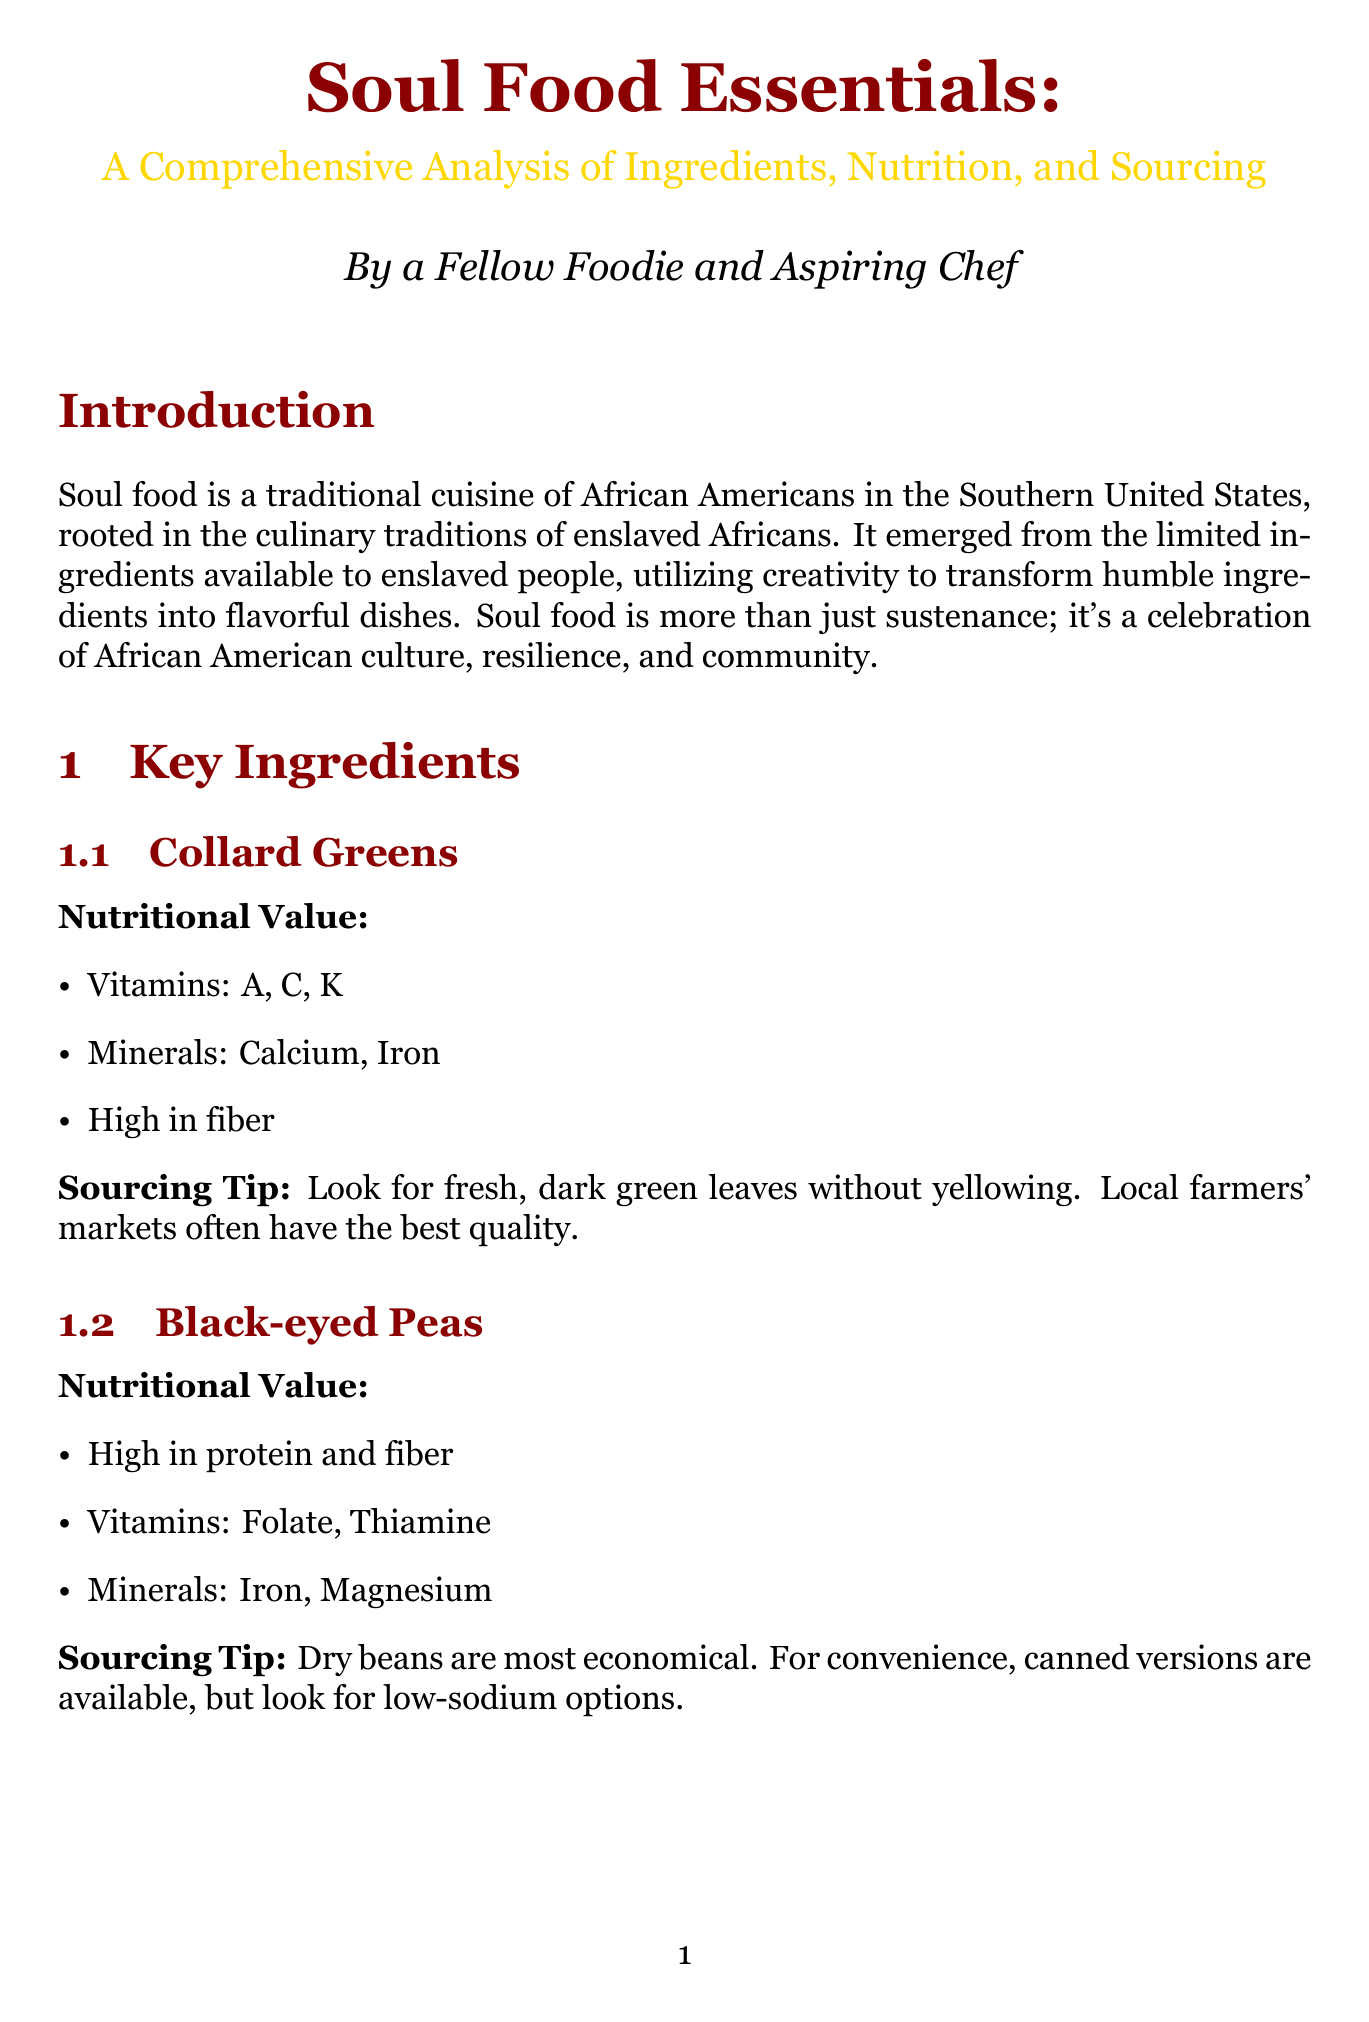What are the key vitamins found in collard greens? Collard greens contain vitamins A, C, and K, as stated in the nutritional value section.
Answer: A, C, K What is a common cooking technique for fried chicken? The document describes frying as a technique commonly used for dishes like fried chicken, indicating its prevalence.
Answer: Frying What is one of the pros of traditional soul food? The document lists several pros, one of which is that it is high in fiber from vegetables and legumes.
Answer: High in fiber What kind of suppliers does Sylvia's specialize in? Sylvia's Soul Food Products is mentioned as specializing in canned and packaged soul food ingredients, highlighting their product focus.
Answer: Canned and packaged soul food ingredients What are the nutritional impacts of slow cooking? The document states that slow cooking enhances digestibility but can lead to some nutrient loss, requiring reasoning about its effects.
Answer: Enhances digestibility, nutrient loss What is a sourcing tip for black-eyed peas? The document advises looking for low-sodium options when choosing canned black-eyed peas for a healthier choice.
Answer: Low-sodium options What initiatives help in cultural preservation of soul food? The document mentions several initiatives, including cooking classes and recipe sharing programs that support the maintenance of culinary heritage.
Answer: Cooking classes What is the nutritional value of sweet potatoes in terms of vitamins? The document indicates that sweet potatoes provide vitamins A, C, and B6, which summarizes their vitamin content effectively.
Answer: A, C, B6 What is a recommended local option for sourcing soul food ingredients? The document lists farmers' markets as a recommended source for fresh produce, emphasizing local purchasing options.
Answer: Farmers' markets 